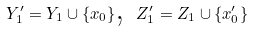Convert formula to latex. <formula><loc_0><loc_0><loc_500><loc_500>Y _ { 1 } ^ { \prime } = Y _ { 1 } \cup \{ x _ { 0 } \} \text {, } Z _ { 1 } ^ { \prime } = Z _ { 1 } \cup \{ x _ { 0 } ^ { \prime } \}</formula> 